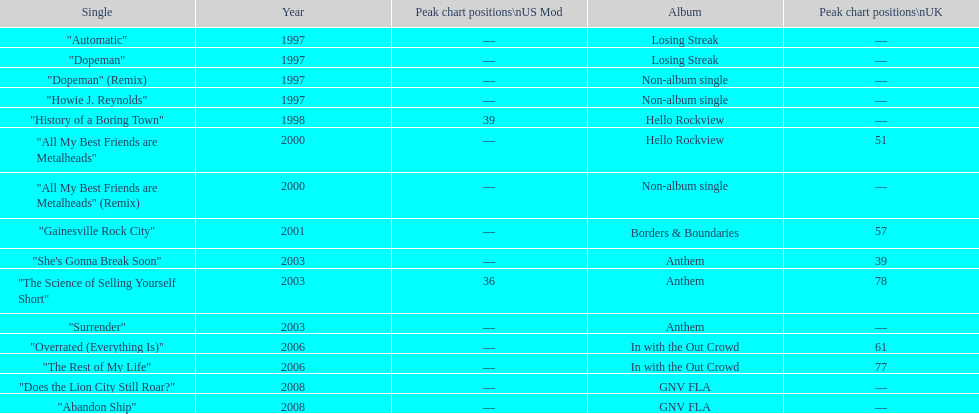In the uk, what was the typical chart placement for their singles? 60.5. 